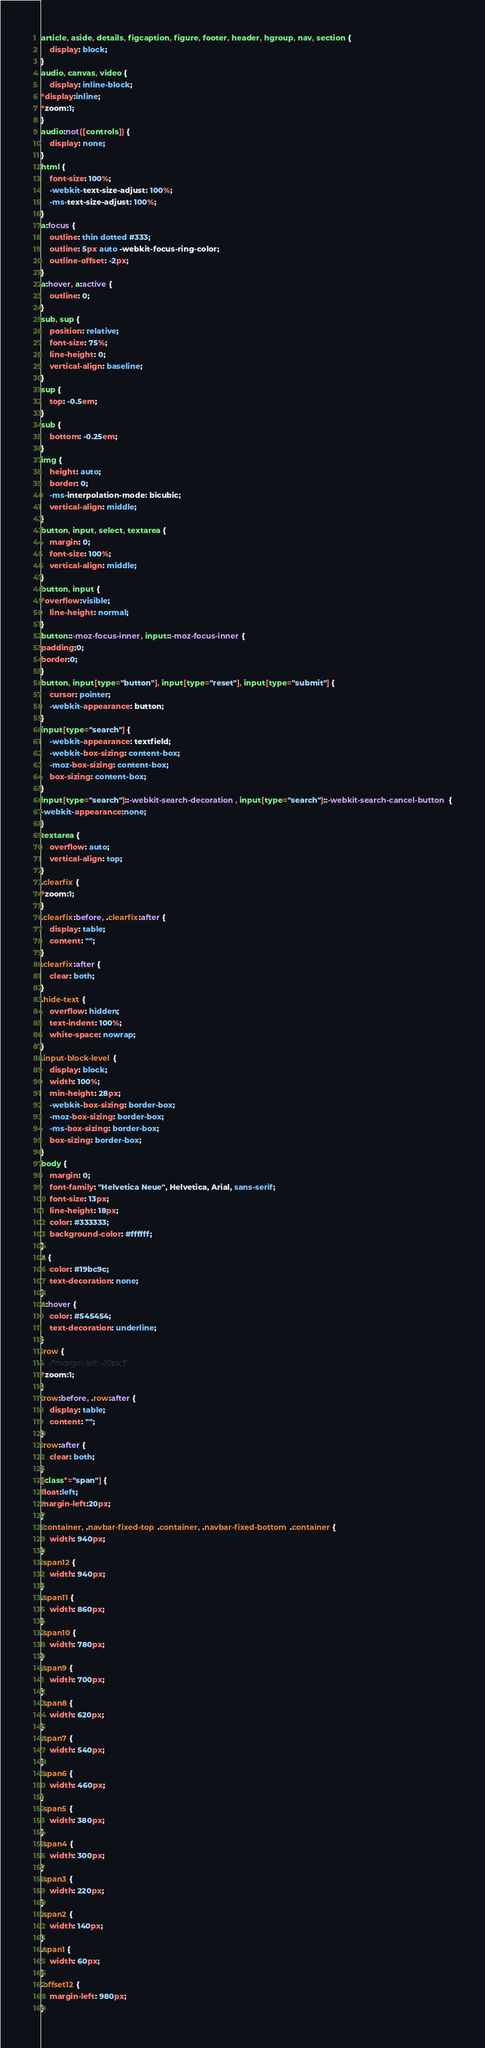Convert code to text. <code><loc_0><loc_0><loc_500><loc_500><_CSS_>article, aside, details, figcaption, figure, footer, header, hgroup, nav, section {
	display: block;
}
audio, canvas, video {
	display: inline-block;
*display:inline;
*zoom:1;
}
audio:not([controls]) {
	display: none;
}
html {
	font-size: 100%;
	-webkit-text-size-adjust: 100%;
	-ms-text-size-adjust: 100%;
}
a:focus {
	outline: thin dotted #333;
	outline: 5px auto -webkit-focus-ring-color;
	outline-offset: -2px;
}
a:hover, a:active {
	outline: 0;
}
sub, sup {
	position: relative;
	font-size: 75%;
	line-height: 0;
	vertical-align: baseline;
}
sup {
	top: -0.5em;
}
sub {
	bottom: -0.25em;
}
img {
	height: auto;
	border: 0;
	-ms-interpolation-mode: bicubic;
	vertical-align: middle;
}
button, input, select, textarea {
	margin: 0;
	font-size: 100%;
	vertical-align: middle;
}
button, input {
*overflow:visible;
	line-height: normal;
}
button::-moz-focus-inner, input::-moz-focus-inner {
padding:0;
border:0;
}
button, input[type="button"], input[type="reset"], input[type="submit"] {
	cursor: pointer;
	-webkit-appearance: button;
}
input[type="search"] {
	-webkit-appearance: textfield;
	-webkit-box-sizing: content-box;
	-moz-box-sizing: content-box;
	box-sizing: content-box;
}
input[type="search"]::-webkit-search-decoration, input[type="search"]::-webkit-search-cancel-button {
-webkit-appearance:none;
}
textarea {
	overflow: auto;
	vertical-align: top;
}
.clearfix {
*zoom:1;
}
.clearfix:before, .clearfix:after {
	display: table;
	content: "";
}
.clearfix:after {
	clear: both;
}
.hide-text {
	overflow: hidden;
	text-indent: 100%;
	white-space: nowrap;
}
.input-block-level {
	display: block;
	width: 100%;
	min-height: 28px;
	-webkit-box-sizing: border-box;
	-moz-box-sizing: border-box;
	-ms-box-sizing: border-box;
	box-sizing: border-box;
}
body {
	margin: 0;
	font-family: "Helvetica Neue", Helvetica, Arial, sans-serif;
	font-size: 13px;
	line-height: 18px;
	color: #333333;
	background-color: #ffffff;
}
a {
	color: #19bc9c;
	text-decoration: none;
}
a:hover {
	color: #545454;
	text-decoration: underline;
}
.row {
	/*margin-left: -20px;*/
*zoom:1;
}
.row:before, .row:after {
	display: table;
	content: "";
}
.row:after {
	clear: both;
}
[class*="span"] {
float:left;
margin-left:20px;
}
.container, .navbar-fixed-top .container, .navbar-fixed-bottom .container {
	width: 940px;
}
.span12 {
	width: 940px;
}
.span11 {
	width: 860px;
}
.span10 {
	width: 780px;
}
.span9 {
	width: 700px;
}
.span8 {
	width: 620px;
}
.span7 {
	width: 540px;
}
.span6 {
	width: 460px;
}
.span5 {
	width: 380px;
}
.span4 {
	width: 300px;
}
.span3 {
	width: 220px;
}
.span2 {
	width: 140px;
}
.span1 {
	width: 60px;
}
.offset12 {
	margin-left: 980px;
}</code> 